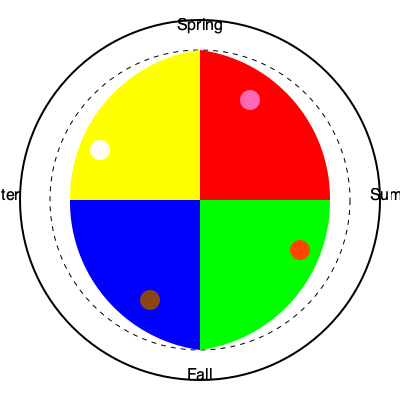Based on the color wheel and seasonal flower bloom patterns shown in the diagram, which season would be most appropriate for planting flowers that produce predominantly blue blooms to complement the existing garden color scheme? To answer this question, we need to analyze the color wheel and its relation to seasonal flower bloom patterns:

1. The color wheel is divided into four main segments, each representing a season.
2. Spring is at the top (red-yellow), summer on the right (red-green), fall at the bottom (green-blue), and winter on the left (blue-yellow).
3. The flower icons represent typical bloom colors for each season:
   - Spring: Pink (light red)
   - Summer: Orange (red-yellow mix)
   - Fall: Brown (muted red-green mix)
   - Winter: White (absence of color)
4. Blue is positioned in the bottom-left quadrant of the color wheel, between fall and winter.
5. In color theory, complementary colors are those opposite each other on the color wheel.
6. The complement of blue is orange, which is prominent in the summer section.
7. To create a balanced and vibrant color scheme, planting predominantly blue flowers would complement the existing orange blooms of summer.
8. However, blue flowers typically bloom in late spring to early summer, aligning with the transition between spring and summer seasons.

Therefore, the most appropriate season for planting flowers that produce predominantly blue blooms would be late spring, as they will bloom and complement the existing summer color scheme.
Answer: Late spring 